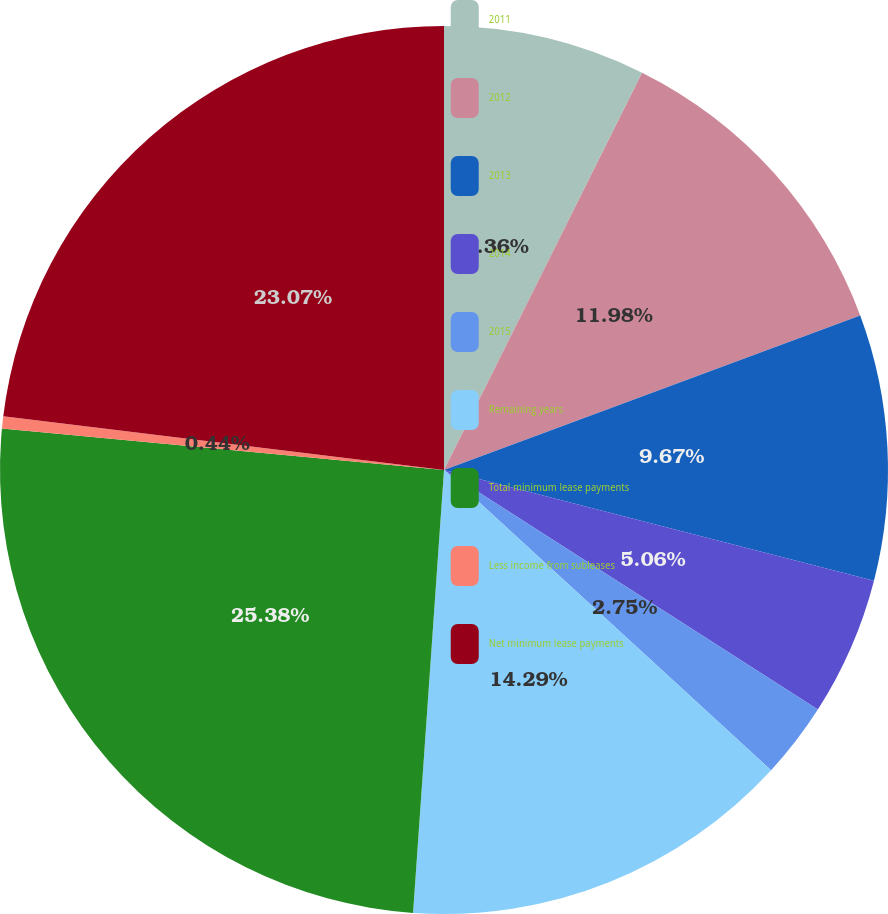Convert chart. <chart><loc_0><loc_0><loc_500><loc_500><pie_chart><fcel>2011<fcel>2012<fcel>2013<fcel>2014<fcel>2015<fcel>Remaining years<fcel>Total minimum lease payments<fcel>Less income from subleases<fcel>Net minimum lease payments<nl><fcel>7.36%<fcel>11.98%<fcel>9.67%<fcel>5.06%<fcel>2.75%<fcel>14.29%<fcel>25.38%<fcel>0.44%<fcel>23.07%<nl></chart> 